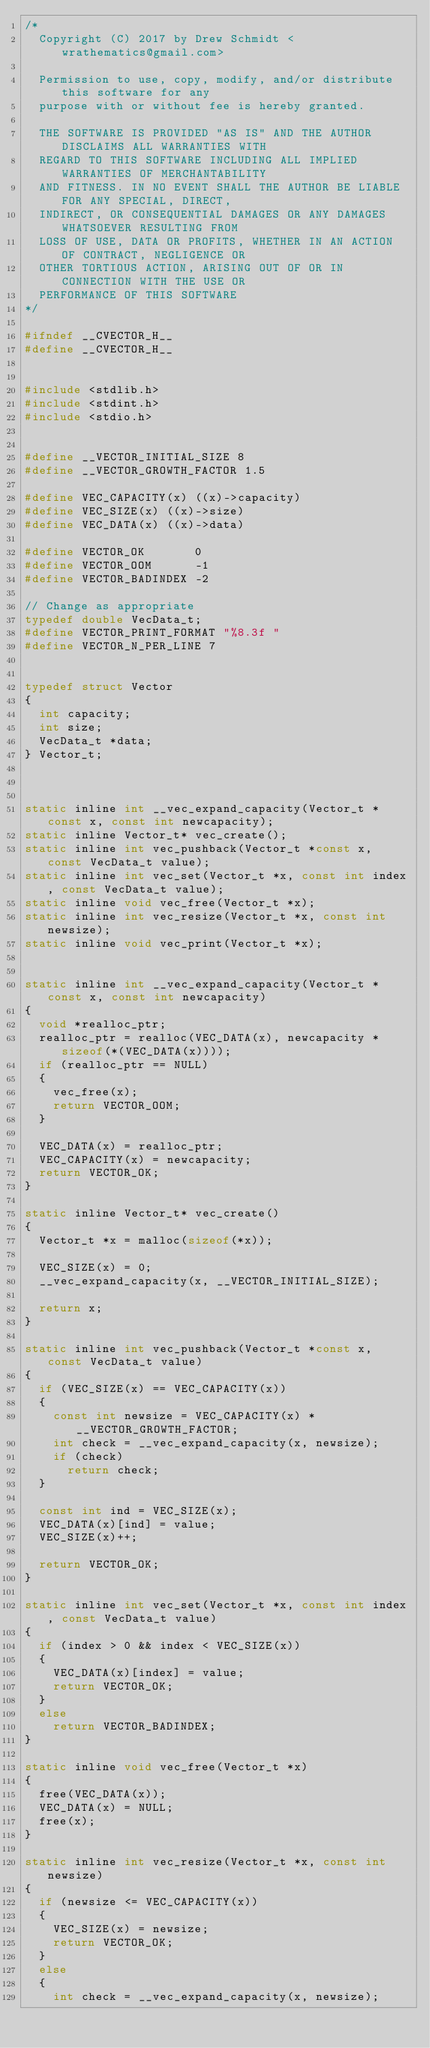Convert code to text. <code><loc_0><loc_0><loc_500><loc_500><_C_>/* 
  Copyright (C) 2017 by Drew Schmidt <wrathematics@gmail.com>
  
  Permission to use, copy, modify, and/or distribute this software for any
  purpose with or without fee is hereby granted.
  
  THE SOFTWARE IS PROVIDED "AS IS" AND THE AUTHOR DISCLAIMS ALL WARRANTIES WITH
  REGARD TO THIS SOFTWARE INCLUDING ALL IMPLIED WARRANTIES OF MERCHANTABILITY
  AND FITNESS. IN NO EVENT SHALL THE AUTHOR BE LIABLE FOR ANY SPECIAL, DIRECT,
  INDIRECT, OR CONSEQUENTIAL DAMAGES OR ANY DAMAGES WHATSOEVER RESULTING FROM
  LOSS OF USE, DATA OR PROFITS, WHETHER IN AN ACTION OF CONTRACT, NEGLIGENCE OR
  OTHER TORTIOUS ACTION, ARISING OUT OF OR IN CONNECTION WITH THE USE OR
  PERFORMANCE OF THIS SOFTWARE
*/

#ifndef __CVECTOR_H__
#define __CVECTOR_H__


#include <stdlib.h>
#include <stdint.h>
#include <stdio.h>


#define __VECTOR_INITIAL_SIZE 8
#define __VECTOR_GROWTH_FACTOR 1.5

#define VEC_CAPACITY(x) ((x)->capacity)
#define VEC_SIZE(x) ((x)->size)
#define VEC_DATA(x) ((x)->data)

#define VECTOR_OK       0
#define VECTOR_OOM      -1
#define VECTOR_BADINDEX -2

// Change as appropriate
typedef double VecData_t;
#define VECTOR_PRINT_FORMAT "%8.3f "
#define VECTOR_N_PER_LINE 7


typedef struct Vector
{
  int capacity;
  int size;
  VecData_t *data;
} Vector_t;



static inline int __vec_expand_capacity(Vector_t *const x, const int newcapacity);
static inline Vector_t* vec_create();
static inline int vec_pushback(Vector_t *const x, const VecData_t value);
static inline int vec_set(Vector_t *x, const int index, const VecData_t value);
static inline void vec_free(Vector_t *x);
static inline int vec_resize(Vector_t *x, const int newsize);
static inline void vec_print(Vector_t *x);


static inline int __vec_expand_capacity(Vector_t *const x, const int newcapacity)
{
  void *realloc_ptr;
  realloc_ptr = realloc(VEC_DATA(x), newcapacity * sizeof(*(VEC_DATA(x))));
  if (realloc_ptr == NULL)
  {
    vec_free(x);
    return VECTOR_OOM;
  }
  
  VEC_DATA(x) = realloc_ptr;
  VEC_CAPACITY(x) = newcapacity;
  return VECTOR_OK;
}

static inline Vector_t* vec_create()
{
  Vector_t *x = malloc(sizeof(*x));
  
  VEC_SIZE(x) = 0;
  __vec_expand_capacity(x, __VECTOR_INITIAL_SIZE);
  
  return x;
}

static inline int vec_pushback(Vector_t *const x, const VecData_t value)
{
  if (VEC_SIZE(x) == VEC_CAPACITY(x))
  {
    const int newsize = VEC_CAPACITY(x) * __VECTOR_GROWTH_FACTOR;
    int check = __vec_expand_capacity(x, newsize);
    if (check)
      return check;
  }
  
  const int ind = VEC_SIZE(x);
  VEC_DATA(x)[ind] = value;
  VEC_SIZE(x)++;
  
  return VECTOR_OK;
}

static inline int vec_set(Vector_t *x, const int index, const VecData_t value)
{
  if (index > 0 && index < VEC_SIZE(x))
  {
    VEC_DATA(x)[index] = value;
    return VECTOR_OK;
  }
  else
    return VECTOR_BADINDEX;
}

static inline void vec_free(Vector_t *x)
{
  free(VEC_DATA(x));
  VEC_DATA(x) = NULL;
  free(x);
}

static inline int vec_resize(Vector_t *x, const int newsize)
{
  if (newsize <= VEC_CAPACITY(x))
  {
    VEC_SIZE(x) = newsize;
    return VECTOR_OK;
  }
  else
  {
    int check = __vec_expand_capacity(x, newsize);</code> 